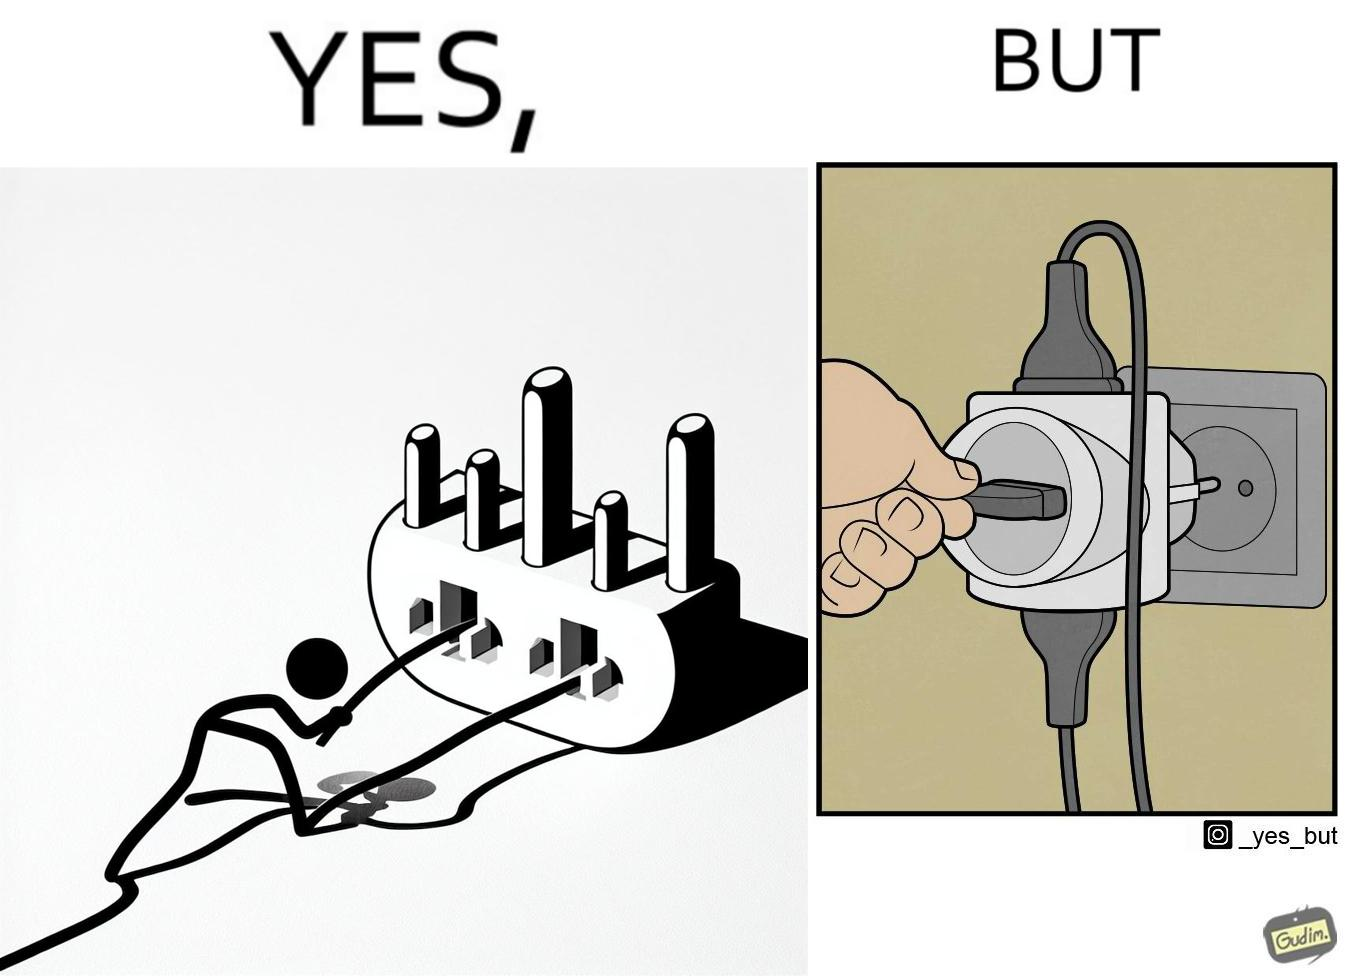What is shown in the left half versus the right half of this image? In the left part of the image: a pin being pulled off from a multi pin plug socket In the right part of the image: the multi pin plug is getting pulled off from the plug 